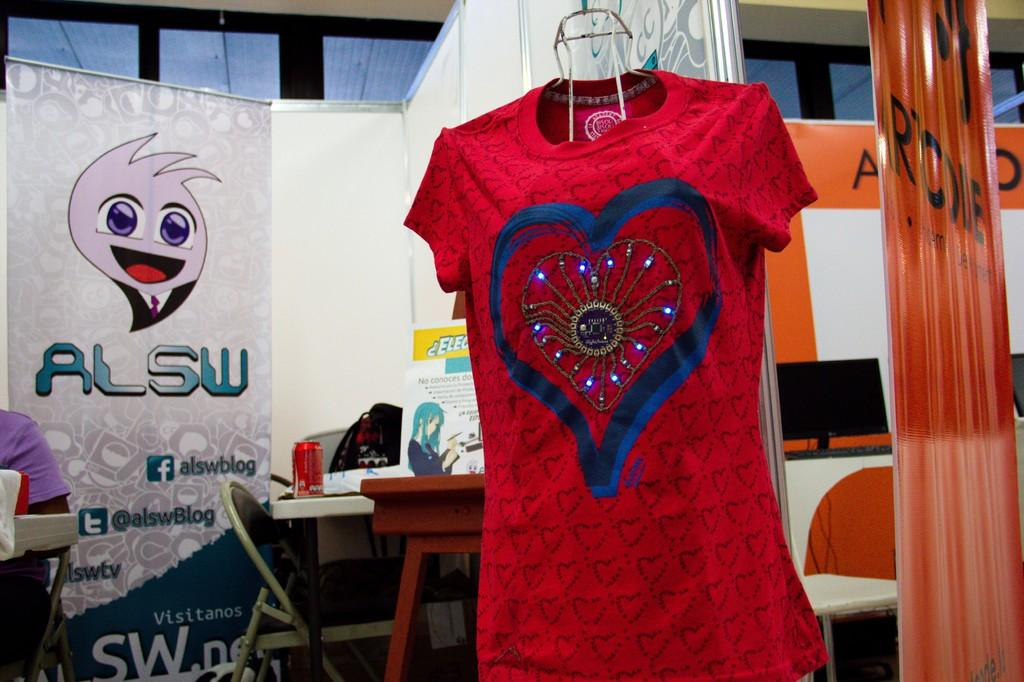What can be seen in the background of the image? There are posters, a chair, and a table in the background. What is on the table in the image? There is a monitor, additional posters, and a tin on the table. What color is the t-shirt hanging in the scene? The t-shirt hanging in the scene is red. Can you see a nest in the image? There is no nest present in the image. Is there a sail visible in the scene? There is no sail present in the image. 